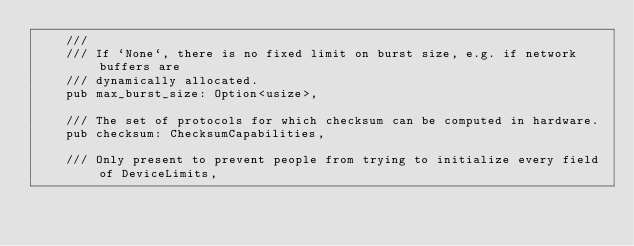Convert code to text. <code><loc_0><loc_0><loc_500><loc_500><_Rust_>    ///
    /// If `None`, there is no fixed limit on burst size, e.g. if network buffers are
    /// dynamically allocated.
    pub max_burst_size: Option<usize>,

    /// The set of protocols for which checksum can be computed in hardware.
    pub checksum: ChecksumCapabilities,

    /// Only present to prevent people from trying to initialize every field of DeviceLimits,</code> 